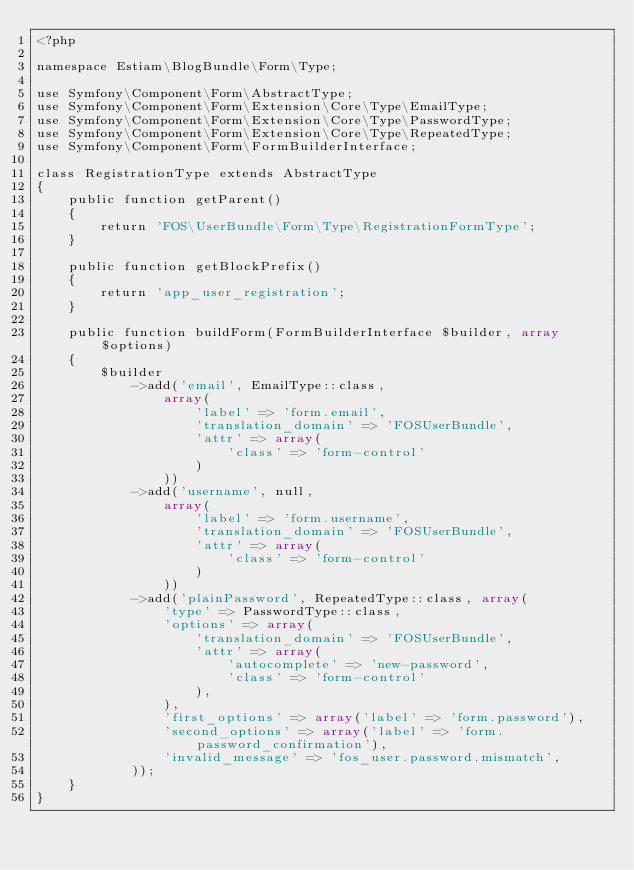Convert code to text. <code><loc_0><loc_0><loc_500><loc_500><_PHP_><?php

namespace Estiam\BlogBundle\Form\Type;

use Symfony\Component\Form\AbstractType;
use Symfony\Component\Form\Extension\Core\Type\EmailType;
use Symfony\Component\Form\Extension\Core\Type\PasswordType;
use Symfony\Component\Form\Extension\Core\Type\RepeatedType;
use Symfony\Component\Form\FormBuilderInterface;

class RegistrationType extends AbstractType
{
    public function getParent()
    {
        return 'FOS\UserBundle\Form\Type\RegistrationFormType';
    }

    public function getBlockPrefix()
    {
        return 'app_user_registration';
    }

    public function buildForm(FormBuilderInterface $builder, array $options)
    {
        $builder
            ->add('email', EmailType::class,
                array(
                    'label' => 'form.email',
                    'translation_domain' => 'FOSUserBundle',
                    'attr' => array(
                        'class' => 'form-control'
                    )
                ))
            ->add('username', null,
                array(
                    'label' => 'form.username',
                    'translation_domain' => 'FOSUserBundle',
                    'attr' => array(
                        'class' => 'form-control'
                    )
                ))
            ->add('plainPassword', RepeatedType::class, array(
                'type' => PasswordType::class,
                'options' => array(
                    'translation_domain' => 'FOSUserBundle',
                    'attr' => array(
                        'autocomplete' => 'new-password',
                        'class' => 'form-control'
                    ),
                ),
                'first_options' => array('label' => 'form.password'),
                'second_options' => array('label' => 'form.password_confirmation'),
                'invalid_message' => 'fos_user.password.mismatch',
            ));
    }
}
</code> 